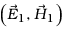Convert formula to latex. <formula><loc_0><loc_0><loc_500><loc_500>\left ( \vec { E } _ { 1 } , \vec { H } _ { 1 } \right )</formula> 